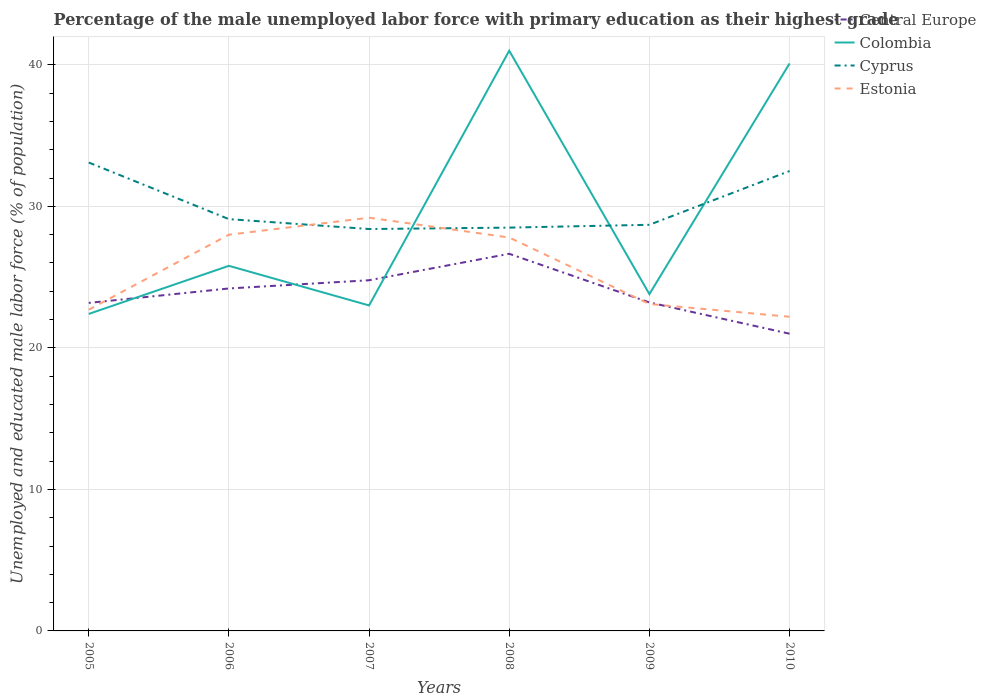Does the line corresponding to Colombia intersect with the line corresponding to Central Europe?
Provide a succinct answer. Yes. Is the number of lines equal to the number of legend labels?
Your answer should be compact. Yes. Across all years, what is the maximum percentage of the unemployed male labor force with primary education in Cyprus?
Provide a succinct answer. 28.4. What is the total percentage of the unemployed male labor force with primary education in Estonia in the graph?
Offer a very short reply. 4.7. What is the difference between the highest and the second highest percentage of the unemployed male labor force with primary education in Cyprus?
Keep it short and to the point. 4.7. What is the difference between the highest and the lowest percentage of the unemployed male labor force with primary education in Colombia?
Your answer should be compact. 2. Is the percentage of the unemployed male labor force with primary education in Cyprus strictly greater than the percentage of the unemployed male labor force with primary education in Central Europe over the years?
Your answer should be compact. No. How many years are there in the graph?
Make the answer very short. 6. How are the legend labels stacked?
Keep it short and to the point. Vertical. What is the title of the graph?
Offer a terse response. Percentage of the male unemployed labor force with primary education as their highest grade. What is the label or title of the Y-axis?
Your answer should be compact. Unemployed and educated male labor force (% of population). What is the Unemployed and educated male labor force (% of population) of Central Europe in 2005?
Keep it short and to the point. 23.18. What is the Unemployed and educated male labor force (% of population) in Colombia in 2005?
Your response must be concise. 22.4. What is the Unemployed and educated male labor force (% of population) of Cyprus in 2005?
Keep it short and to the point. 33.1. What is the Unemployed and educated male labor force (% of population) in Estonia in 2005?
Your answer should be very brief. 22.7. What is the Unemployed and educated male labor force (% of population) in Central Europe in 2006?
Offer a terse response. 24.2. What is the Unemployed and educated male labor force (% of population) of Colombia in 2006?
Give a very brief answer. 25.8. What is the Unemployed and educated male labor force (% of population) in Cyprus in 2006?
Offer a terse response. 29.1. What is the Unemployed and educated male labor force (% of population) in Central Europe in 2007?
Make the answer very short. 24.78. What is the Unemployed and educated male labor force (% of population) of Colombia in 2007?
Give a very brief answer. 23. What is the Unemployed and educated male labor force (% of population) of Cyprus in 2007?
Give a very brief answer. 28.4. What is the Unemployed and educated male labor force (% of population) in Estonia in 2007?
Provide a short and direct response. 29.2. What is the Unemployed and educated male labor force (% of population) in Central Europe in 2008?
Your response must be concise. 26.65. What is the Unemployed and educated male labor force (% of population) of Cyprus in 2008?
Your response must be concise. 28.5. What is the Unemployed and educated male labor force (% of population) of Estonia in 2008?
Provide a short and direct response. 27.8. What is the Unemployed and educated male labor force (% of population) of Central Europe in 2009?
Your answer should be very brief. 23.21. What is the Unemployed and educated male labor force (% of population) in Colombia in 2009?
Provide a short and direct response. 23.8. What is the Unemployed and educated male labor force (% of population) of Cyprus in 2009?
Your answer should be very brief. 28.7. What is the Unemployed and educated male labor force (% of population) in Estonia in 2009?
Your answer should be compact. 23.1. What is the Unemployed and educated male labor force (% of population) in Central Europe in 2010?
Offer a terse response. 21. What is the Unemployed and educated male labor force (% of population) of Colombia in 2010?
Make the answer very short. 40.1. What is the Unemployed and educated male labor force (% of population) of Cyprus in 2010?
Your response must be concise. 32.5. What is the Unemployed and educated male labor force (% of population) of Estonia in 2010?
Provide a short and direct response. 22.2. Across all years, what is the maximum Unemployed and educated male labor force (% of population) of Central Europe?
Offer a very short reply. 26.65. Across all years, what is the maximum Unemployed and educated male labor force (% of population) in Colombia?
Provide a short and direct response. 41. Across all years, what is the maximum Unemployed and educated male labor force (% of population) in Cyprus?
Ensure brevity in your answer.  33.1. Across all years, what is the maximum Unemployed and educated male labor force (% of population) of Estonia?
Offer a very short reply. 29.2. Across all years, what is the minimum Unemployed and educated male labor force (% of population) in Central Europe?
Offer a very short reply. 21. Across all years, what is the minimum Unemployed and educated male labor force (% of population) of Colombia?
Provide a succinct answer. 22.4. Across all years, what is the minimum Unemployed and educated male labor force (% of population) in Cyprus?
Your answer should be very brief. 28.4. Across all years, what is the minimum Unemployed and educated male labor force (% of population) in Estonia?
Make the answer very short. 22.2. What is the total Unemployed and educated male labor force (% of population) in Central Europe in the graph?
Offer a very short reply. 143.02. What is the total Unemployed and educated male labor force (% of population) of Colombia in the graph?
Offer a terse response. 176.1. What is the total Unemployed and educated male labor force (% of population) of Cyprus in the graph?
Offer a very short reply. 180.3. What is the total Unemployed and educated male labor force (% of population) in Estonia in the graph?
Give a very brief answer. 153. What is the difference between the Unemployed and educated male labor force (% of population) in Central Europe in 2005 and that in 2006?
Give a very brief answer. -1.02. What is the difference between the Unemployed and educated male labor force (% of population) of Colombia in 2005 and that in 2006?
Give a very brief answer. -3.4. What is the difference between the Unemployed and educated male labor force (% of population) of Central Europe in 2005 and that in 2007?
Provide a succinct answer. -1.6. What is the difference between the Unemployed and educated male labor force (% of population) of Central Europe in 2005 and that in 2008?
Provide a succinct answer. -3.47. What is the difference between the Unemployed and educated male labor force (% of population) in Colombia in 2005 and that in 2008?
Your answer should be compact. -18.6. What is the difference between the Unemployed and educated male labor force (% of population) in Cyprus in 2005 and that in 2008?
Your answer should be compact. 4.6. What is the difference between the Unemployed and educated male labor force (% of population) in Estonia in 2005 and that in 2008?
Make the answer very short. -5.1. What is the difference between the Unemployed and educated male labor force (% of population) in Central Europe in 2005 and that in 2009?
Your answer should be very brief. -0.03. What is the difference between the Unemployed and educated male labor force (% of population) of Colombia in 2005 and that in 2009?
Make the answer very short. -1.4. What is the difference between the Unemployed and educated male labor force (% of population) of Central Europe in 2005 and that in 2010?
Provide a short and direct response. 2.18. What is the difference between the Unemployed and educated male labor force (% of population) of Colombia in 2005 and that in 2010?
Offer a terse response. -17.7. What is the difference between the Unemployed and educated male labor force (% of population) of Cyprus in 2005 and that in 2010?
Provide a short and direct response. 0.6. What is the difference between the Unemployed and educated male labor force (% of population) of Estonia in 2005 and that in 2010?
Ensure brevity in your answer.  0.5. What is the difference between the Unemployed and educated male labor force (% of population) in Central Europe in 2006 and that in 2007?
Offer a very short reply. -0.58. What is the difference between the Unemployed and educated male labor force (% of population) of Cyprus in 2006 and that in 2007?
Provide a short and direct response. 0.7. What is the difference between the Unemployed and educated male labor force (% of population) in Estonia in 2006 and that in 2007?
Ensure brevity in your answer.  -1.2. What is the difference between the Unemployed and educated male labor force (% of population) of Central Europe in 2006 and that in 2008?
Provide a succinct answer. -2.45. What is the difference between the Unemployed and educated male labor force (% of population) in Colombia in 2006 and that in 2008?
Provide a succinct answer. -15.2. What is the difference between the Unemployed and educated male labor force (% of population) in Cyprus in 2006 and that in 2008?
Your answer should be very brief. 0.6. What is the difference between the Unemployed and educated male labor force (% of population) of Estonia in 2006 and that in 2008?
Offer a very short reply. 0.2. What is the difference between the Unemployed and educated male labor force (% of population) of Central Europe in 2006 and that in 2009?
Provide a short and direct response. 0.99. What is the difference between the Unemployed and educated male labor force (% of population) in Estonia in 2006 and that in 2009?
Give a very brief answer. 4.9. What is the difference between the Unemployed and educated male labor force (% of population) in Central Europe in 2006 and that in 2010?
Make the answer very short. 3.2. What is the difference between the Unemployed and educated male labor force (% of population) in Colombia in 2006 and that in 2010?
Keep it short and to the point. -14.3. What is the difference between the Unemployed and educated male labor force (% of population) in Cyprus in 2006 and that in 2010?
Give a very brief answer. -3.4. What is the difference between the Unemployed and educated male labor force (% of population) in Estonia in 2006 and that in 2010?
Offer a terse response. 5.8. What is the difference between the Unemployed and educated male labor force (% of population) in Central Europe in 2007 and that in 2008?
Your answer should be very brief. -1.87. What is the difference between the Unemployed and educated male labor force (% of population) in Cyprus in 2007 and that in 2008?
Keep it short and to the point. -0.1. What is the difference between the Unemployed and educated male labor force (% of population) in Central Europe in 2007 and that in 2009?
Keep it short and to the point. 1.57. What is the difference between the Unemployed and educated male labor force (% of population) of Colombia in 2007 and that in 2009?
Your response must be concise. -0.8. What is the difference between the Unemployed and educated male labor force (% of population) in Central Europe in 2007 and that in 2010?
Keep it short and to the point. 3.78. What is the difference between the Unemployed and educated male labor force (% of population) of Colombia in 2007 and that in 2010?
Give a very brief answer. -17.1. What is the difference between the Unemployed and educated male labor force (% of population) of Estonia in 2007 and that in 2010?
Make the answer very short. 7. What is the difference between the Unemployed and educated male labor force (% of population) in Central Europe in 2008 and that in 2009?
Ensure brevity in your answer.  3.44. What is the difference between the Unemployed and educated male labor force (% of population) in Cyprus in 2008 and that in 2009?
Your answer should be compact. -0.2. What is the difference between the Unemployed and educated male labor force (% of population) of Central Europe in 2008 and that in 2010?
Your answer should be very brief. 5.65. What is the difference between the Unemployed and educated male labor force (% of population) of Colombia in 2008 and that in 2010?
Provide a succinct answer. 0.9. What is the difference between the Unemployed and educated male labor force (% of population) of Central Europe in 2009 and that in 2010?
Keep it short and to the point. 2.21. What is the difference between the Unemployed and educated male labor force (% of population) in Colombia in 2009 and that in 2010?
Offer a terse response. -16.3. What is the difference between the Unemployed and educated male labor force (% of population) of Estonia in 2009 and that in 2010?
Offer a very short reply. 0.9. What is the difference between the Unemployed and educated male labor force (% of population) in Central Europe in 2005 and the Unemployed and educated male labor force (% of population) in Colombia in 2006?
Offer a terse response. -2.62. What is the difference between the Unemployed and educated male labor force (% of population) in Central Europe in 2005 and the Unemployed and educated male labor force (% of population) in Cyprus in 2006?
Your response must be concise. -5.92. What is the difference between the Unemployed and educated male labor force (% of population) in Central Europe in 2005 and the Unemployed and educated male labor force (% of population) in Estonia in 2006?
Your answer should be very brief. -4.82. What is the difference between the Unemployed and educated male labor force (% of population) of Colombia in 2005 and the Unemployed and educated male labor force (% of population) of Cyprus in 2006?
Ensure brevity in your answer.  -6.7. What is the difference between the Unemployed and educated male labor force (% of population) of Colombia in 2005 and the Unemployed and educated male labor force (% of population) of Estonia in 2006?
Keep it short and to the point. -5.6. What is the difference between the Unemployed and educated male labor force (% of population) in Cyprus in 2005 and the Unemployed and educated male labor force (% of population) in Estonia in 2006?
Give a very brief answer. 5.1. What is the difference between the Unemployed and educated male labor force (% of population) of Central Europe in 2005 and the Unemployed and educated male labor force (% of population) of Colombia in 2007?
Make the answer very short. 0.18. What is the difference between the Unemployed and educated male labor force (% of population) of Central Europe in 2005 and the Unemployed and educated male labor force (% of population) of Cyprus in 2007?
Provide a short and direct response. -5.22. What is the difference between the Unemployed and educated male labor force (% of population) of Central Europe in 2005 and the Unemployed and educated male labor force (% of population) of Estonia in 2007?
Your answer should be very brief. -6.02. What is the difference between the Unemployed and educated male labor force (% of population) of Colombia in 2005 and the Unemployed and educated male labor force (% of population) of Cyprus in 2007?
Provide a short and direct response. -6. What is the difference between the Unemployed and educated male labor force (% of population) in Colombia in 2005 and the Unemployed and educated male labor force (% of population) in Estonia in 2007?
Give a very brief answer. -6.8. What is the difference between the Unemployed and educated male labor force (% of population) in Cyprus in 2005 and the Unemployed and educated male labor force (% of population) in Estonia in 2007?
Offer a terse response. 3.9. What is the difference between the Unemployed and educated male labor force (% of population) in Central Europe in 2005 and the Unemployed and educated male labor force (% of population) in Colombia in 2008?
Offer a very short reply. -17.82. What is the difference between the Unemployed and educated male labor force (% of population) in Central Europe in 2005 and the Unemployed and educated male labor force (% of population) in Cyprus in 2008?
Offer a terse response. -5.32. What is the difference between the Unemployed and educated male labor force (% of population) in Central Europe in 2005 and the Unemployed and educated male labor force (% of population) in Estonia in 2008?
Offer a very short reply. -4.62. What is the difference between the Unemployed and educated male labor force (% of population) of Colombia in 2005 and the Unemployed and educated male labor force (% of population) of Estonia in 2008?
Provide a short and direct response. -5.4. What is the difference between the Unemployed and educated male labor force (% of population) of Cyprus in 2005 and the Unemployed and educated male labor force (% of population) of Estonia in 2008?
Offer a terse response. 5.3. What is the difference between the Unemployed and educated male labor force (% of population) of Central Europe in 2005 and the Unemployed and educated male labor force (% of population) of Colombia in 2009?
Offer a terse response. -0.62. What is the difference between the Unemployed and educated male labor force (% of population) of Central Europe in 2005 and the Unemployed and educated male labor force (% of population) of Cyprus in 2009?
Offer a very short reply. -5.52. What is the difference between the Unemployed and educated male labor force (% of population) in Central Europe in 2005 and the Unemployed and educated male labor force (% of population) in Estonia in 2009?
Provide a succinct answer. 0.08. What is the difference between the Unemployed and educated male labor force (% of population) of Colombia in 2005 and the Unemployed and educated male labor force (% of population) of Cyprus in 2009?
Give a very brief answer. -6.3. What is the difference between the Unemployed and educated male labor force (% of population) in Colombia in 2005 and the Unemployed and educated male labor force (% of population) in Estonia in 2009?
Give a very brief answer. -0.7. What is the difference between the Unemployed and educated male labor force (% of population) of Cyprus in 2005 and the Unemployed and educated male labor force (% of population) of Estonia in 2009?
Your response must be concise. 10. What is the difference between the Unemployed and educated male labor force (% of population) of Central Europe in 2005 and the Unemployed and educated male labor force (% of population) of Colombia in 2010?
Offer a terse response. -16.92. What is the difference between the Unemployed and educated male labor force (% of population) in Central Europe in 2005 and the Unemployed and educated male labor force (% of population) in Cyprus in 2010?
Provide a succinct answer. -9.32. What is the difference between the Unemployed and educated male labor force (% of population) of Central Europe in 2005 and the Unemployed and educated male labor force (% of population) of Estonia in 2010?
Your answer should be very brief. 0.98. What is the difference between the Unemployed and educated male labor force (% of population) in Colombia in 2005 and the Unemployed and educated male labor force (% of population) in Cyprus in 2010?
Provide a short and direct response. -10.1. What is the difference between the Unemployed and educated male labor force (% of population) of Colombia in 2005 and the Unemployed and educated male labor force (% of population) of Estonia in 2010?
Make the answer very short. 0.2. What is the difference between the Unemployed and educated male labor force (% of population) of Cyprus in 2005 and the Unemployed and educated male labor force (% of population) of Estonia in 2010?
Your answer should be compact. 10.9. What is the difference between the Unemployed and educated male labor force (% of population) of Central Europe in 2006 and the Unemployed and educated male labor force (% of population) of Colombia in 2007?
Your response must be concise. 1.2. What is the difference between the Unemployed and educated male labor force (% of population) in Central Europe in 2006 and the Unemployed and educated male labor force (% of population) in Cyprus in 2007?
Provide a short and direct response. -4.2. What is the difference between the Unemployed and educated male labor force (% of population) of Central Europe in 2006 and the Unemployed and educated male labor force (% of population) of Estonia in 2007?
Provide a succinct answer. -5. What is the difference between the Unemployed and educated male labor force (% of population) in Colombia in 2006 and the Unemployed and educated male labor force (% of population) in Cyprus in 2007?
Offer a very short reply. -2.6. What is the difference between the Unemployed and educated male labor force (% of population) in Colombia in 2006 and the Unemployed and educated male labor force (% of population) in Estonia in 2007?
Give a very brief answer. -3.4. What is the difference between the Unemployed and educated male labor force (% of population) of Central Europe in 2006 and the Unemployed and educated male labor force (% of population) of Colombia in 2008?
Make the answer very short. -16.8. What is the difference between the Unemployed and educated male labor force (% of population) in Central Europe in 2006 and the Unemployed and educated male labor force (% of population) in Cyprus in 2008?
Ensure brevity in your answer.  -4.3. What is the difference between the Unemployed and educated male labor force (% of population) of Central Europe in 2006 and the Unemployed and educated male labor force (% of population) of Estonia in 2008?
Your response must be concise. -3.6. What is the difference between the Unemployed and educated male labor force (% of population) of Colombia in 2006 and the Unemployed and educated male labor force (% of population) of Cyprus in 2008?
Keep it short and to the point. -2.7. What is the difference between the Unemployed and educated male labor force (% of population) in Colombia in 2006 and the Unemployed and educated male labor force (% of population) in Estonia in 2008?
Offer a terse response. -2. What is the difference between the Unemployed and educated male labor force (% of population) in Cyprus in 2006 and the Unemployed and educated male labor force (% of population) in Estonia in 2008?
Your answer should be very brief. 1.3. What is the difference between the Unemployed and educated male labor force (% of population) of Central Europe in 2006 and the Unemployed and educated male labor force (% of population) of Colombia in 2009?
Make the answer very short. 0.4. What is the difference between the Unemployed and educated male labor force (% of population) of Central Europe in 2006 and the Unemployed and educated male labor force (% of population) of Cyprus in 2009?
Offer a terse response. -4.5. What is the difference between the Unemployed and educated male labor force (% of population) of Central Europe in 2006 and the Unemployed and educated male labor force (% of population) of Estonia in 2009?
Make the answer very short. 1.1. What is the difference between the Unemployed and educated male labor force (% of population) of Colombia in 2006 and the Unemployed and educated male labor force (% of population) of Cyprus in 2009?
Your response must be concise. -2.9. What is the difference between the Unemployed and educated male labor force (% of population) of Cyprus in 2006 and the Unemployed and educated male labor force (% of population) of Estonia in 2009?
Ensure brevity in your answer.  6. What is the difference between the Unemployed and educated male labor force (% of population) in Central Europe in 2006 and the Unemployed and educated male labor force (% of population) in Colombia in 2010?
Provide a succinct answer. -15.9. What is the difference between the Unemployed and educated male labor force (% of population) of Central Europe in 2006 and the Unemployed and educated male labor force (% of population) of Cyprus in 2010?
Your answer should be very brief. -8.3. What is the difference between the Unemployed and educated male labor force (% of population) in Central Europe in 2006 and the Unemployed and educated male labor force (% of population) in Estonia in 2010?
Your answer should be very brief. 2. What is the difference between the Unemployed and educated male labor force (% of population) of Cyprus in 2006 and the Unemployed and educated male labor force (% of population) of Estonia in 2010?
Offer a terse response. 6.9. What is the difference between the Unemployed and educated male labor force (% of population) in Central Europe in 2007 and the Unemployed and educated male labor force (% of population) in Colombia in 2008?
Ensure brevity in your answer.  -16.22. What is the difference between the Unemployed and educated male labor force (% of population) in Central Europe in 2007 and the Unemployed and educated male labor force (% of population) in Cyprus in 2008?
Provide a succinct answer. -3.72. What is the difference between the Unemployed and educated male labor force (% of population) of Central Europe in 2007 and the Unemployed and educated male labor force (% of population) of Estonia in 2008?
Offer a very short reply. -3.02. What is the difference between the Unemployed and educated male labor force (% of population) in Colombia in 2007 and the Unemployed and educated male labor force (% of population) in Estonia in 2008?
Make the answer very short. -4.8. What is the difference between the Unemployed and educated male labor force (% of population) of Central Europe in 2007 and the Unemployed and educated male labor force (% of population) of Colombia in 2009?
Provide a succinct answer. 0.98. What is the difference between the Unemployed and educated male labor force (% of population) in Central Europe in 2007 and the Unemployed and educated male labor force (% of population) in Cyprus in 2009?
Offer a very short reply. -3.92. What is the difference between the Unemployed and educated male labor force (% of population) of Central Europe in 2007 and the Unemployed and educated male labor force (% of population) of Estonia in 2009?
Make the answer very short. 1.68. What is the difference between the Unemployed and educated male labor force (% of population) in Cyprus in 2007 and the Unemployed and educated male labor force (% of population) in Estonia in 2009?
Provide a short and direct response. 5.3. What is the difference between the Unemployed and educated male labor force (% of population) of Central Europe in 2007 and the Unemployed and educated male labor force (% of population) of Colombia in 2010?
Provide a short and direct response. -15.32. What is the difference between the Unemployed and educated male labor force (% of population) in Central Europe in 2007 and the Unemployed and educated male labor force (% of population) in Cyprus in 2010?
Give a very brief answer. -7.72. What is the difference between the Unemployed and educated male labor force (% of population) of Central Europe in 2007 and the Unemployed and educated male labor force (% of population) of Estonia in 2010?
Ensure brevity in your answer.  2.58. What is the difference between the Unemployed and educated male labor force (% of population) of Colombia in 2007 and the Unemployed and educated male labor force (% of population) of Estonia in 2010?
Offer a terse response. 0.8. What is the difference between the Unemployed and educated male labor force (% of population) of Central Europe in 2008 and the Unemployed and educated male labor force (% of population) of Colombia in 2009?
Offer a very short reply. 2.85. What is the difference between the Unemployed and educated male labor force (% of population) of Central Europe in 2008 and the Unemployed and educated male labor force (% of population) of Cyprus in 2009?
Provide a short and direct response. -2.05. What is the difference between the Unemployed and educated male labor force (% of population) of Central Europe in 2008 and the Unemployed and educated male labor force (% of population) of Estonia in 2009?
Provide a succinct answer. 3.55. What is the difference between the Unemployed and educated male labor force (% of population) of Colombia in 2008 and the Unemployed and educated male labor force (% of population) of Estonia in 2009?
Your response must be concise. 17.9. What is the difference between the Unemployed and educated male labor force (% of population) in Central Europe in 2008 and the Unemployed and educated male labor force (% of population) in Colombia in 2010?
Ensure brevity in your answer.  -13.45. What is the difference between the Unemployed and educated male labor force (% of population) in Central Europe in 2008 and the Unemployed and educated male labor force (% of population) in Cyprus in 2010?
Offer a terse response. -5.85. What is the difference between the Unemployed and educated male labor force (% of population) of Central Europe in 2008 and the Unemployed and educated male labor force (% of population) of Estonia in 2010?
Your answer should be very brief. 4.45. What is the difference between the Unemployed and educated male labor force (% of population) in Colombia in 2008 and the Unemployed and educated male labor force (% of population) in Cyprus in 2010?
Offer a terse response. 8.5. What is the difference between the Unemployed and educated male labor force (% of population) in Cyprus in 2008 and the Unemployed and educated male labor force (% of population) in Estonia in 2010?
Your answer should be compact. 6.3. What is the difference between the Unemployed and educated male labor force (% of population) in Central Europe in 2009 and the Unemployed and educated male labor force (% of population) in Colombia in 2010?
Offer a very short reply. -16.89. What is the difference between the Unemployed and educated male labor force (% of population) in Central Europe in 2009 and the Unemployed and educated male labor force (% of population) in Cyprus in 2010?
Your answer should be very brief. -9.29. What is the difference between the Unemployed and educated male labor force (% of population) in Central Europe in 2009 and the Unemployed and educated male labor force (% of population) in Estonia in 2010?
Offer a terse response. 1.01. What is the difference between the Unemployed and educated male labor force (% of population) in Colombia in 2009 and the Unemployed and educated male labor force (% of population) in Cyprus in 2010?
Make the answer very short. -8.7. What is the difference between the Unemployed and educated male labor force (% of population) of Colombia in 2009 and the Unemployed and educated male labor force (% of population) of Estonia in 2010?
Give a very brief answer. 1.6. What is the average Unemployed and educated male labor force (% of population) of Central Europe per year?
Your answer should be compact. 23.84. What is the average Unemployed and educated male labor force (% of population) in Colombia per year?
Ensure brevity in your answer.  29.35. What is the average Unemployed and educated male labor force (% of population) in Cyprus per year?
Ensure brevity in your answer.  30.05. In the year 2005, what is the difference between the Unemployed and educated male labor force (% of population) of Central Europe and Unemployed and educated male labor force (% of population) of Colombia?
Provide a short and direct response. 0.78. In the year 2005, what is the difference between the Unemployed and educated male labor force (% of population) in Central Europe and Unemployed and educated male labor force (% of population) in Cyprus?
Provide a short and direct response. -9.92. In the year 2005, what is the difference between the Unemployed and educated male labor force (% of population) of Central Europe and Unemployed and educated male labor force (% of population) of Estonia?
Offer a terse response. 0.48. In the year 2005, what is the difference between the Unemployed and educated male labor force (% of population) of Colombia and Unemployed and educated male labor force (% of population) of Cyprus?
Your answer should be compact. -10.7. In the year 2005, what is the difference between the Unemployed and educated male labor force (% of population) in Colombia and Unemployed and educated male labor force (% of population) in Estonia?
Keep it short and to the point. -0.3. In the year 2005, what is the difference between the Unemployed and educated male labor force (% of population) of Cyprus and Unemployed and educated male labor force (% of population) of Estonia?
Your answer should be compact. 10.4. In the year 2006, what is the difference between the Unemployed and educated male labor force (% of population) of Central Europe and Unemployed and educated male labor force (% of population) of Colombia?
Your answer should be very brief. -1.6. In the year 2006, what is the difference between the Unemployed and educated male labor force (% of population) of Central Europe and Unemployed and educated male labor force (% of population) of Cyprus?
Give a very brief answer. -4.9. In the year 2006, what is the difference between the Unemployed and educated male labor force (% of population) in Central Europe and Unemployed and educated male labor force (% of population) in Estonia?
Provide a short and direct response. -3.8. In the year 2006, what is the difference between the Unemployed and educated male labor force (% of population) in Colombia and Unemployed and educated male labor force (% of population) in Cyprus?
Offer a very short reply. -3.3. In the year 2006, what is the difference between the Unemployed and educated male labor force (% of population) in Colombia and Unemployed and educated male labor force (% of population) in Estonia?
Give a very brief answer. -2.2. In the year 2007, what is the difference between the Unemployed and educated male labor force (% of population) in Central Europe and Unemployed and educated male labor force (% of population) in Colombia?
Offer a very short reply. 1.78. In the year 2007, what is the difference between the Unemployed and educated male labor force (% of population) in Central Europe and Unemployed and educated male labor force (% of population) in Cyprus?
Your response must be concise. -3.62. In the year 2007, what is the difference between the Unemployed and educated male labor force (% of population) in Central Europe and Unemployed and educated male labor force (% of population) in Estonia?
Offer a very short reply. -4.42. In the year 2007, what is the difference between the Unemployed and educated male labor force (% of population) in Colombia and Unemployed and educated male labor force (% of population) in Cyprus?
Offer a terse response. -5.4. In the year 2007, what is the difference between the Unemployed and educated male labor force (% of population) in Cyprus and Unemployed and educated male labor force (% of population) in Estonia?
Your response must be concise. -0.8. In the year 2008, what is the difference between the Unemployed and educated male labor force (% of population) in Central Europe and Unemployed and educated male labor force (% of population) in Colombia?
Offer a very short reply. -14.35. In the year 2008, what is the difference between the Unemployed and educated male labor force (% of population) of Central Europe and Unemployed and educated male labor force (% of population) of Cyprus?
Provide a short and direct response. -1.85. In the year 2008, what is the difference between the Unemployed and educated male labor force (% of population) in Central Europe and Unemployed and educated male labor force (% of population) in Estonia?
Your answer should be compact. -1.15. In the year 2008, what is the difference between the Unemployed and educated male labor force (% of population) in Colombia and Unemployed and educated male labor force (% of population) in Cyprus?
Offer a terse response. 12.5. In the year 2009, what is the difference between the Unemployed and educated male labor force (% of population) of Central Europe and Unemployed and educated male labor force (% of population) of Colombia?
Provide a short and direct response. -0.59. In the year 2009, what is the difference between the Unemployed and educated male labor force (% of population) in Central Europe and Unemployed and educated male labor force (% of population) in Cyprus?
Give a very brief answer. -5.49. In the year 2009, what is the difference between the Unemployed and educated male labor force (% of population) of Central Europe and Unemployed and educated male labor force (% of population) of Estonia?
Give a very brief answer. 0.11. In the year 2010, what is the difference between the Unemployed and educated male labor force (% of population) in Central Europe and Unemployed and educated male labor force (% of population) in Colombia?
Your answer should be compact. -19.1. In the year 2010, what is the difference between the Unemployed and educated male labor force (% of population) of Central Europe and Unemployed and educated male labor force (% of population) of Cyprus?
Make the answer very short. -11.5. In the year 2010, what is the difference between the Unemployed and educated male labor force (% of population) of Central Europe and Unemployed and educated male labor force (% of population) of Estonia?
Your response must be concise. -1.2. In the year 2010, what is the difference between the Unemployed and educated male labor force (% of population) in Colombia and Unemployed and educated male labor force (% of population) in Cyprus?
Give a very brief answer. 7.6. In the year 2010, what is the difference between the Unemployed and educated male labor force (% of population) in Colombia and Unemployed and educated male labor force (% of population) in Estonia?
Ensure brevity in your answer.  17.9. In the year 2010, what is the difference between the Unemployed and educated male labor force (% of population) in Cyprus and Unemployed and educated male labor force (% of population) in Estonia?
Your answer should be compact. 10.3. What is the ratio of the Unemployed and educated male labor force (% of population) in Central Europe in 2005 to that in 2006?
Ensure brevity in your answer.  0.96. What is the ratio of the Unemployed and educated male labor force (% of population) of Colombia in 2005 to that in 2006?
Provide a short and direct response. 0.87. What is the ratio of the Unemployed and educated male labor force (% of population) in Cyprus in 2005 to that in 2006?
Your response must be concise. 1.14. What is the ratio of the Unemployed and educated male labor force (% of population) in Estonia in 2005 to that in 2006?
Provide a succinct answer. 0.81. What is the ratio of the Unemployed and educated male labor force (% of population) of Central Europe in 2005 to that in 2007?
Provide a succinct answer. 0.94. What is the ratio of the Unemployed and educated male labor force (% of population) in Colombia in 2005 to that in 2007?
Your answer should be very brief. 0.97. What is the ratio of the Unemployed and educated male labor force (% of population) of Cyprus in 2005 to that in 2007?
Offer a very short reply. 1.17. What is the ratio of the Unemployed and educated male labor force (% of population) in Estonia in 2005 to that in 2007?
Offer a very short reply. 0.78. What is the ratio of the Unemployed and educated male labor force (% of population) of Central Europe in 2005 to that in 2008?
Ensure brevity in your answer.  0.87. What is the ratio of the Unemployed and educated male labor force (% of population) in Colombia in 2005 to that in 2008?
Provide a succinct answer. 0.55. What is the ratio of the Unemployed and educated male labor force (% of population) of Cyprus in 2005 to that in 2008?
Give a very brief answer. 1.16. What is the ratio of the Unemployed and educated male labor force (% of population) of Estonia in 2005 to that in 2008?
Your answer should be compact. 0.82. What is the ratio of the Unemployed and educated male labor force (% of population) of Cyprus in 2005 to that in 2009?
Give a very brief answer. 1.15. What is the ratio of the Unemployed and educated male labor force (% of population) of Estonia in 2005 to that in 2009?
Provide a short and direct response. 0.98. What is the ratio of the Unemployed and educated male labor force (% of population) of Central Europe in 2005 to that in 2010?
Ensure brevity in your answer.  1.1. What is the ratio of the Unemployed and educated male labor force (% of population) of Colombia in 2005 to that in 2010?
Offer a terse response. 0.56. What is the ratio of the Unemployed and educated male labor force (% of population) in Cyprus in 2005 to that in 2010?
Your answer should be very brief. 1.02. What is the ratio of the Unemployed and educated male labor force (% of population) of Estonia in 2005 to that in 2010?
Offer a very short reply. 1.02. What is the ratio of the Unemployed and educated male labor force (% of population) in Central Europe in 2006 to that in 2007?
Give a very brief answer. 0.98. What is the ratio of the Unemployed and educated male labor force (% of population) in Colombia in 2006 to that in 2007?
Make the answer very short. 1.12. What is the ratio of the Unemployed and educated male labor force (% of population) in Cyprus in 2006 to that in 2007?
Offer a terse response. 1.02. What is the ratio of the Unemployed and educated male labor force (% of population) of Estonia in 2006 to that in 2007?
Your answer should be compact. 0.96. What is the ratio of the Unemployed and educated male labor force (% of population) in Central Europe in 2006 to that in 2008?
Offer a very short reply. 0.91. What is the ratio of the Unemployed and educated male labor force (% of population) in Colombia in 2006 to that in 2008?
Provide a succinct answer. 0.63. What is the ratio of the Unemployed and educated male labor force (% of population) of Cyprus in 2006 to that in 2008?
Ensure brevity in your answer.  1.02. What is the ratio of the Unemployed and educated male labor force (% of population) of Central Europe in 2006 to that in 2009?
Provide a succinct answer. 1.04. What is the ratio of the Unemployed and educated male labor force (% of population) in Colombia in 2006 to that in 2009?
Your answer should be compact. 1.08. What is the ratio of the Unemployed and educated male labor force (% of population) of Cyprus in 2006 to that in 2009?
Keep it short and to the point. 1.01. What is the ratio of the Unemployed and educated male labor force (% of population) of Estonia in 2006 to that in 2009?
Your response must be concise. 1.21. What is the ratio of the Unemployed and educated male labor force (% of population) in Central Europe in 2006 to that in 2010?
Ensure brevity in your answer.  1.15. What is the ratio of the Unemployed and educated male labor force (% of population) of Colombia in 2006 to that in 2010?
Your answer should be very brief. 0.64. What is the ratio of the Unemployed and educated male labor force (% of population) in Cyprus in 2006 to that in 2010?
Provide a short and direct response. 0.9. What is the ratio of the Unemployed and educated male labor force (% of population) of Estonia in 2006 to that in 2010?
Provide a succinct answer. 1.26. What is the ratio of the Unemployed and educated male labor force (% of population) of Central Europe in 2007 to that in 2008?
Offer a very short reply. 0.93. What is the ratio of the Unemployed and educated male labor force (% of population) of Colombia in 2007 to that in 2008?
Provide a succinct answer. 0.56. What is the ratio of the Unemployed and educated male labor force (% of population) of Estonia in 2007 to that in 2008?
Make the answer very short. 1.05. What is the ratio of the Unemployed and educated male labor force (% of population) in Central Europe in 2007 to that in 2009?
Keep it short and to the point. 1.07. What is the ratio of the Unemployed and educated male labor force (% of population) in Colombia in 2007 to that in 2009?
Your response must be concise. 0.97. What is the ratio of the Unemployed and educated male labor force (% of population) in Cyprus in 2007 to that in 2009?
Your answer should be compact. 0.99. What is the ratio of the Unemployed and educated male labor force (% of population) in Estonia in 2007 to that in 2009?
Ensure brevity in your answer.  1.26. What is the ratio of the Unemployed and educated male labor force (% of population) of Central Europe in 2007 to that in 2010?
Make the answer very short. 1.18. What is the ratio of the Unemployed and educated male labor force (% of population) in Colombia in 2007 to that in 2010?
Offer a very short reply. 0.57. What is the ratio of the Unemployed and educated male labor force (% of population) in Cyprus in 2007 to that in 2010?
Give a very brief answer. 0.87. What is the ratio of the Unemployed and educated male labor force (% of population) of Estonia in 2007 to that in 2010?
Your answer should be compact. 1.32. What is the ratio of the Unemployed and educated male labor force (% of population) of Central Europe in 2008 to that in 2009?
Give a very brief answer. 1.15. What is the ratio of the Unemployed and educated male labor force (% of population) of Colombia in 2008 to that in 2009?
Offer a terse response. 1.72. What is the ratio of the Unemployed and educated male labor force (% of population) of Estonia in 2008 to that in 2009?
Your response must be concise. 1.2. What is the ratio of the Unemployed and educated male labor force (% of population) of Central Europe in 2008 to that in 2010?
Your answer should be very brief. 1.27. What is the ratio of the Unemployed and educated male labor force (% of population) of Colombia in 2008 to that in 2010?
Give a very brief answer. 1.02. What is the ratio of the Unemployed and educated male labor force (% of population) in Cyprus in 2008 to that in 2010?
Make the answer very short. 0.88. What is the ratio of the Unemployed and educated male labor force (% of population) in Estonia in 2008 to that in 2010?
Provide a succinct answer. 1.25. What is the ratio of the Unemployed and educated male labor force (% of population) of Central Europe in 2009 to that in 2010?
Provide a short and direct response. 1.11. What is the ratio of the Unemployed and educated male labor force (% of population) in Colombia in 2009 to that in 2010?
Give a very brief answer. 0.59. What is the ratio of the Unemployed and educated male labor force (% of population) of Cyprus in 2009 to that in 2010?
Your answer should be compact. 0.88. What is the ratio of the Unemployed and educated male labor force (% of population) of Estonia in 2009 to that in 2010?
Offer a terse response. 1.04. What is the difference between the highest and the second highest Unemployed and educated male labor force (% of population) in Central Europe?
Your answer should be compact. 1.87. What is the difference between the highest and the second highest Unemployed and educated male labor force (% of population) in Colombia?
Ensure brevity in your answer.  0.9. What is the difference between the highest and the second highest Unemployed and educated male labor force (% of population) of Estonia?
Keep it short and to the point. 1.2. What is the difference between the highest and the lowest Unemployed and educated male labor force (% of population) in Central Europe?
Offer a terse response. 5.65. What is the difference between the highest and the lowest Unemployed and educated male labor force (% of population) of Colombia?
Provide a short and direct response. 18.6. What is the difference between the highest and the lowest Unemployed and educated male labor force (% of population) in Cyprus?
Give a very brief answer. 4.7. 